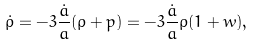Convert formula to latex. <formula><loc_0><loc_0><loc_500><loc_500>\dot { \rho } = - 3 \frac { \dot { a } } a ( \rho + p ) = - 3 \frac { \dot { a } } a \rho ( 1 + w ) ,</formula> 